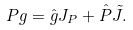Convert formula to latex. <formula><loc_0><loc_0><loc_500><loc_500>P g = \hat { g } J _ { P } + \hat { P } { \tilde { J } } .</formula> 